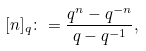<formula> <loc_0><loc_0><loc_500><loc_500>[ n ] _ { q } \colon = \frac { q ^ { n } - q ^ { - n } } { q - q ^ { - 1 } } ,</formula> 